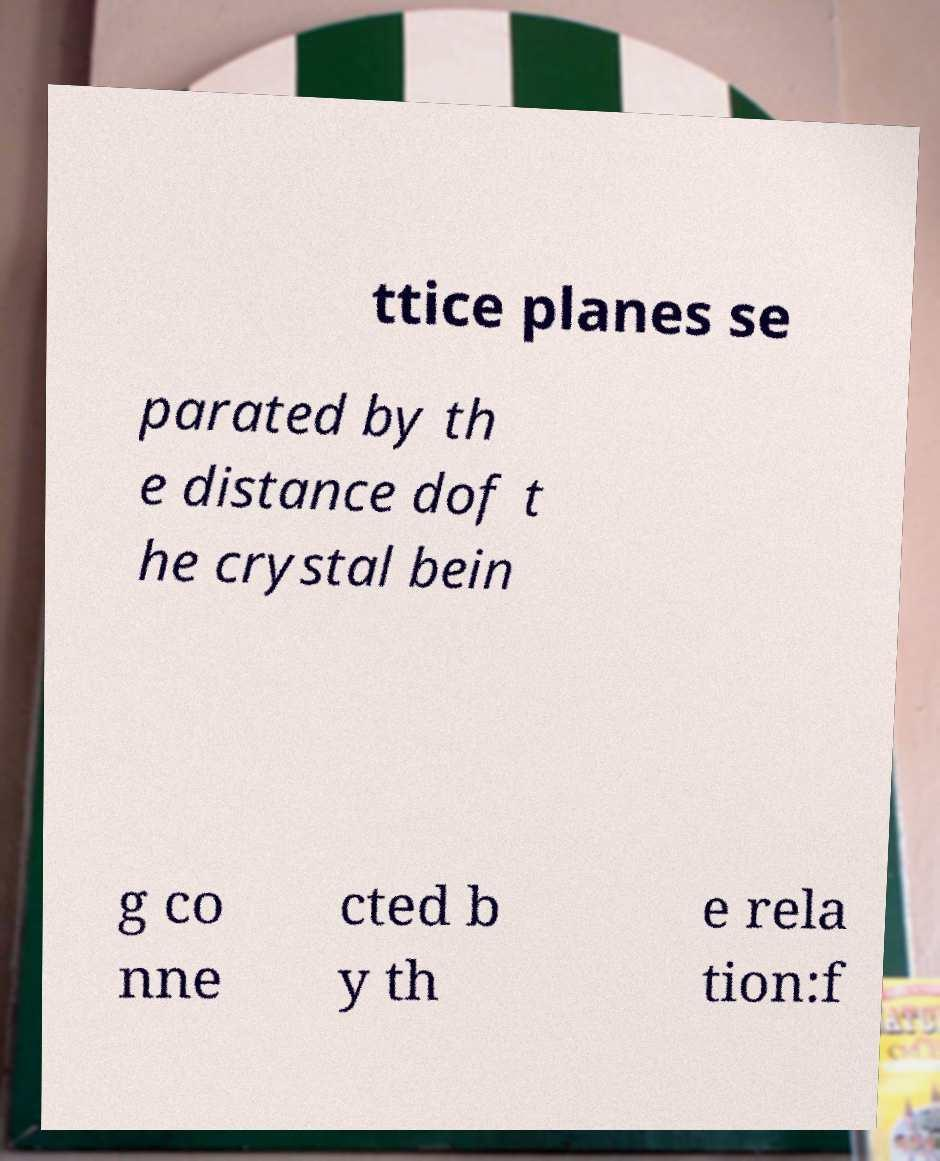I need the written content from this picture converted into text. Can you do that? ttice planes se parated by th e distance dof t he crystal bein g co nne cted b y th e rela tion:f 